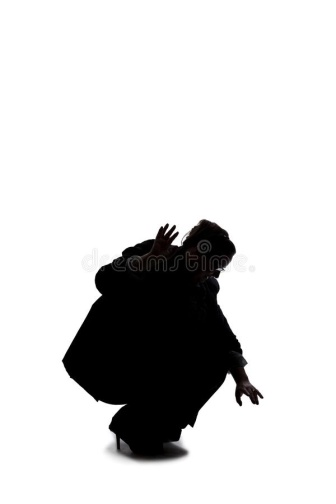What story do you think this image is telling? This image appears to tell a story of suspense and anticipation. The solitary figure crouched and poised as though ready to spring or confront an unseen challenge suggests a moment of high tension. The stark black and white contrast underscores the intensity of the scene, evoking a sense of urgency and focus. Why do you think the background is completely white? The completely white background serves multiple purposes. It isolates the figure, ensuring that all attention is focused on the person’s dramatic pose and form. It also amplifies the starkness and simplicity of the image, making the emotional and narrative impact more striking. The white backdrop might also symbolize a void, an unknown environment, or a space of unlimited possibilities, emphasizing the figure's solitary struggle or readiness. 